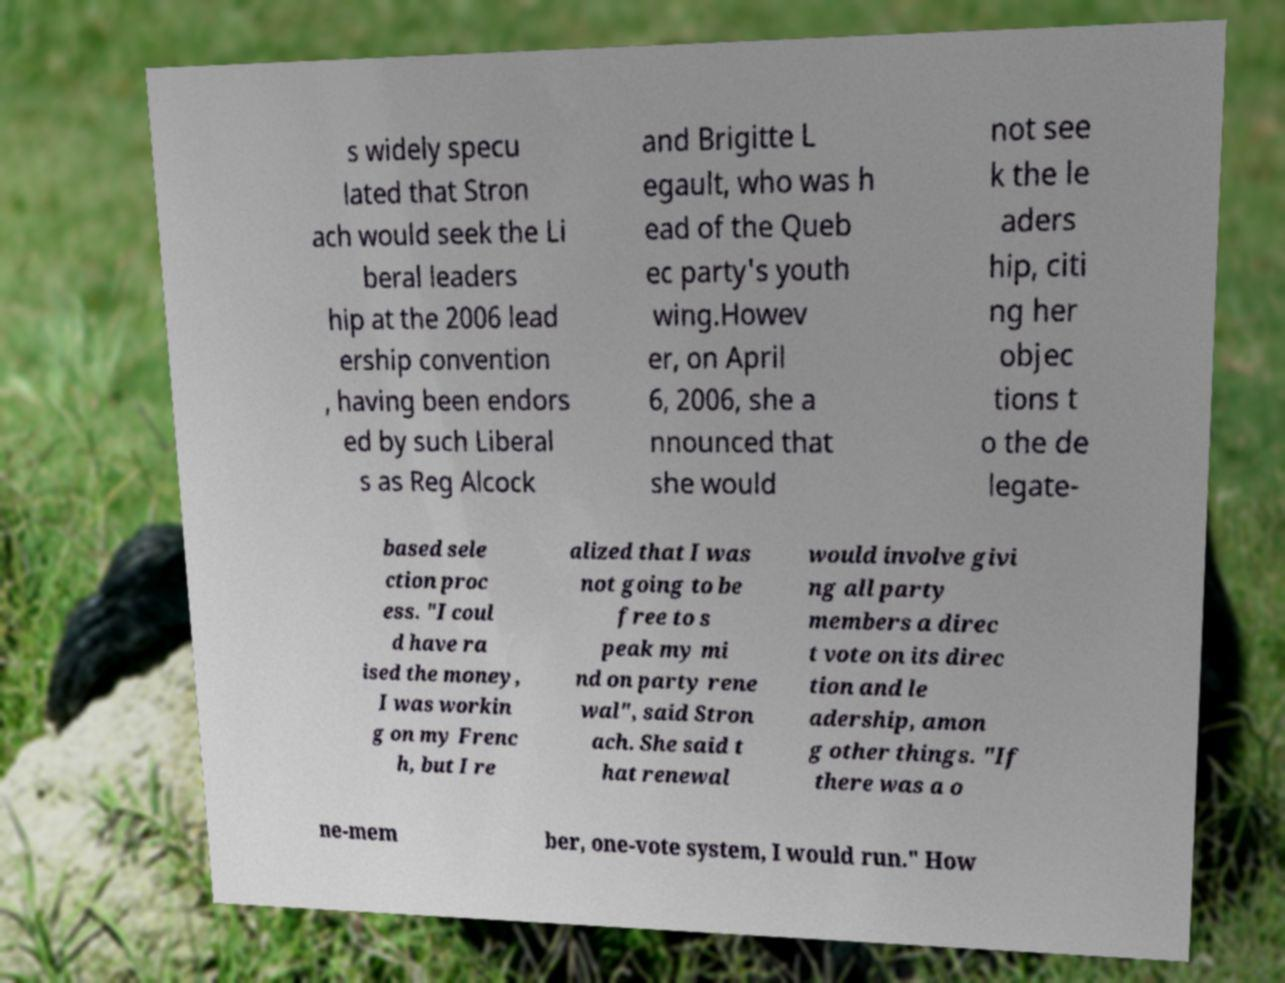Could you assist in decoding the text presented in this image and type it out clearly? s widely specu lated that Stron ach would seek the Li beral leaders hip at the 2006 lead ership convention , having been endors ed by such Liberal s as Reg Alcock and Brigitte L egault, who was h ead of the Queb ec party's youth wing.Howev er, on April 6, 2006, she a nnounced that she would not see k the le aders hip, citi ng her objec tions t o the de legate- based sele ction proc ess. "I coul d have ra ised the money, I was workin g on my Frenc h, but I re alized that I was not going to be free to s peak my mi nd on party rene wal", said Stron ach. She said t hat renewal would involve givi ng all party members a direc t vote on its direc tion and le adership, amon g other things. "If there was a o ne-mem ber, one-vote system, I would run." How 